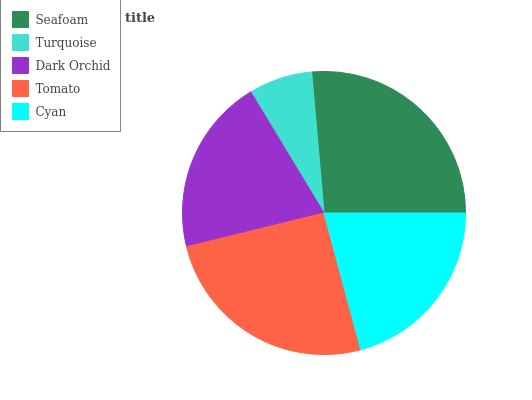Is Turquoise the minimum?
Answer yes or no. Yes. Is Seafoam the maximum?
Answer yes or no. Yes. Is Dark Orchid the minimum?
Answer yes or no. No. Is Dark Orchid the maximum?
Answer yes or no. No. Is Dark Orchid greater than Turquoise?
Answer yes or no. Yes. Is Turquoise less than Dark Orchid?
Answer yes or no. Yes. Is Turquoise greater than Dark Orchid?
Answer yes or no. No. Is Dark Orchid less than Turquoise?
Answer yes or no. No. Is Cyan the high median?
Answer yes or no. Yes. Is Cyan the low median?
Answer yes or no. Yes. Is Turquoise the high median?
Answer yes or no. No. Is Seafoam the low median?
Answer yes or no. No. 